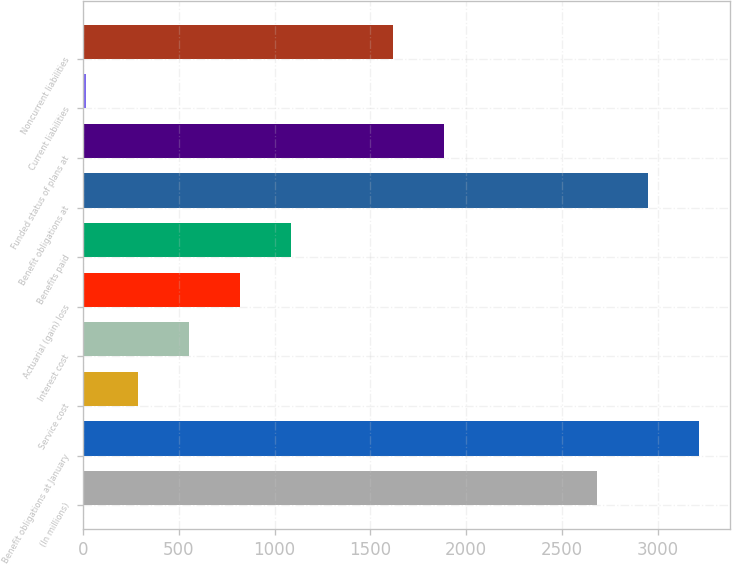<chart> <loc_0><loc_0><loc_500><loc_500><bar_chart><fcel>(In millions)<fcel>Benefit obligations at January<fcel>Service cost<fcel>Interest cost<fcel>Actuarial (gain) loss<fcel>Benefits paid<fcel>Benefit obligations at<fcel>Funded status of plans at<fcel>Current liabilities<fcel>Noncurrent liabilities<nl><fcel>2685<fcel>3218.4<fcel>284.7<fcel>551.4<fcel>818.1<fcel>1084.8<fcel>2951.7<fcel>1884.9<fcel>18<fcel>1618.2<nl></chart> 